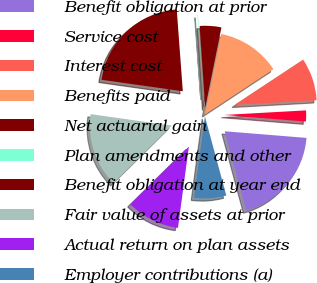Convert chart. <chart><loc_0><loc_0><loc_500><loc_500><pie_chart><fcel>Benefit obligation at prior<fcel>Service cost<fcel>Interest cost<fcel>Benefits paid<fcel>Net actuarial gain<fcel>Plan amendments and other<fcel>Benefit obligation at year end<fcel>Fair value of assets at prior<fcel>Actual return on plan assets<fcel>Employer contributions (a)<nl><fcel>19.51%<fcel>2.17%<fcel>8.4%<fcel>12.55%<fcel>4.25%<fcel>0.1%<fcel>21.59%<fcel>14.63%<fcel>10.48%<fcel>6.33%<nl></chart> 